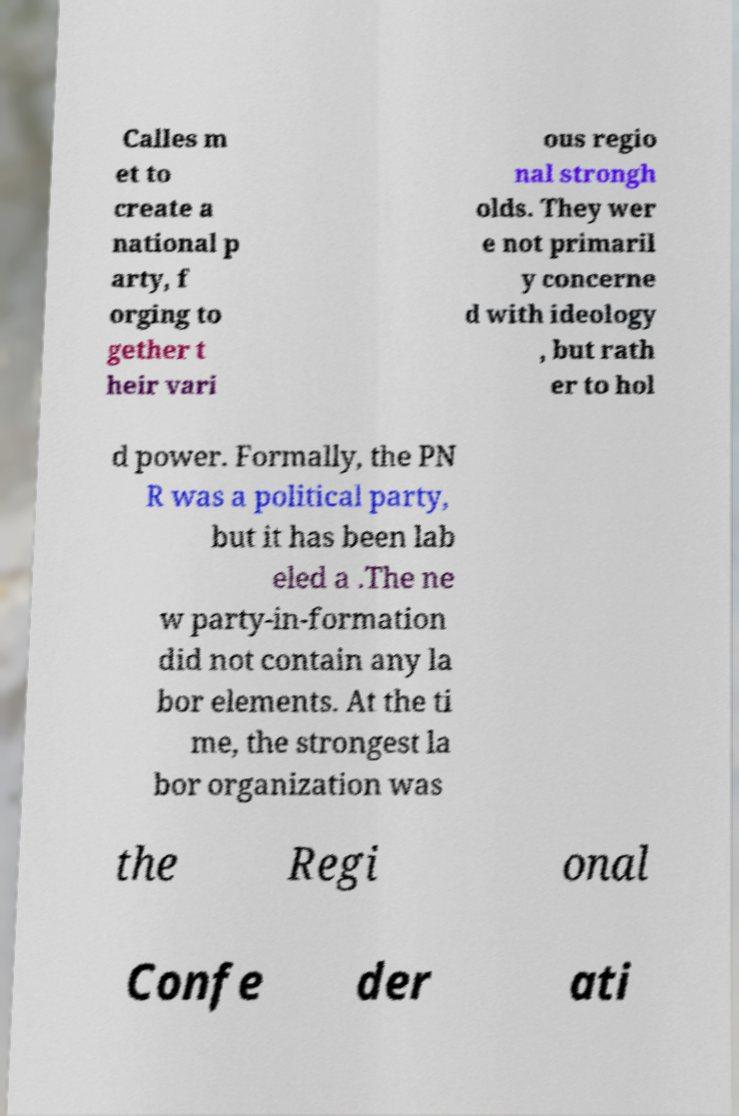Please read and relay the text visible in this image. What does it say? Calles m et to create a national p arty, f orging to gether t heir vari ous regio nal strongh olds. They wer e not primaril y concerne d with ideology , but rath er to hol d power. Formally, the PN R was a political party, but it has been lab eled a .The ne w party-in-formation did not contain any la bor elements. At the ti me, the strongest la bor organization was the Regi onal Confe der ati 